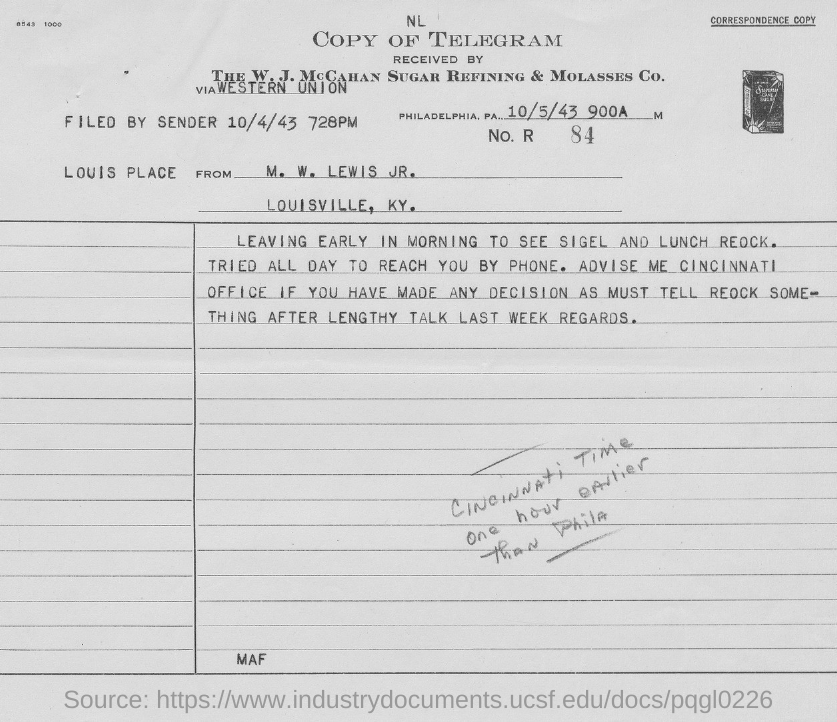List a handful of essential elements in this visual. This letter is from a person named M. W. Lewis Jr. When was the letter filed by the sender? October 4th, 1943 at 7:28 PM. 